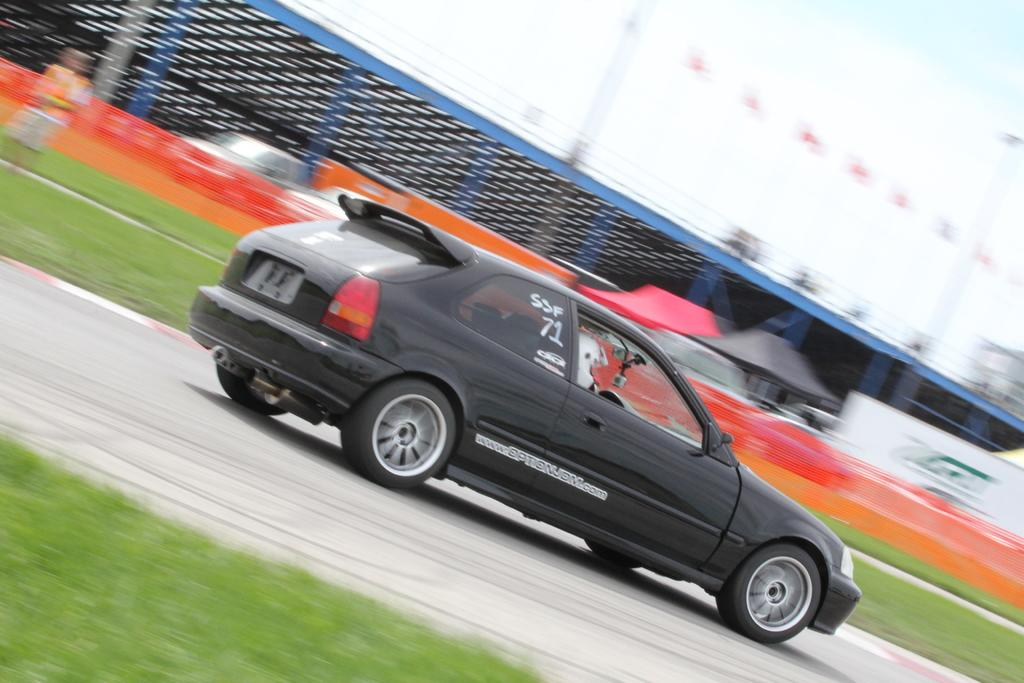What is the main subject in the center of the image? There is a car in the center of the image. Where is the car located? The car is on the road. What can be seen in the background of the image? There is a mesh, men, and sheds in the background of the image. What type of vest is the car wearing in the image? Cars do not wear vests; the question is not applicable to the image. 